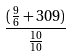Convert formula to latex. <formula><loc_0><loc_0><loc_500><loc_500>\frac { ( \frac { 9 } { 6 } + 3 0 9 ) } { \frac { 1 0 } { 1 0 } }</formula> 